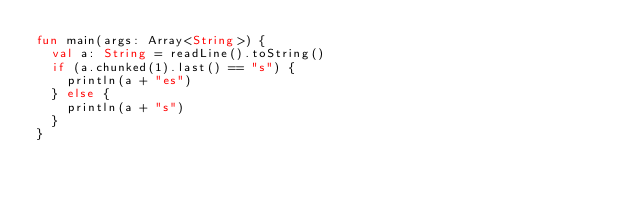<code> <loc_0><loc_0><loc_500><loc_500><_Kotlin_>fun main(args: Array<String>) {
  val a: String = readLine().toString()
  if (a.chunked(1).last() == "s") {
    println(a + "es")
  } else {
    println(a + "s")
  }
}</code> 